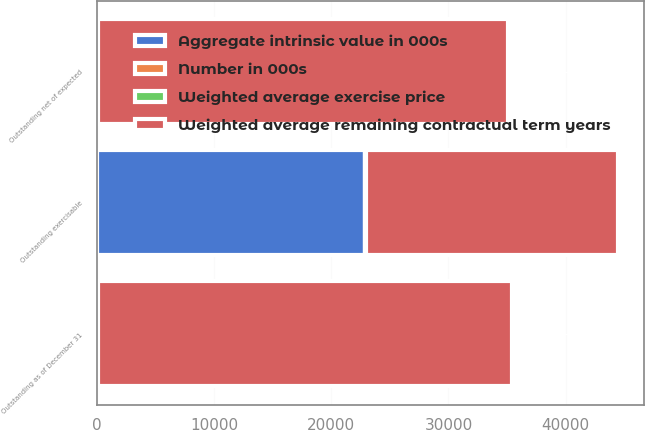Convert chart to OTSL. <chart><loc_0><loc_0><loc_500><loc_500><stacked_bar_chart><ecel><fcel>Outstanding as of December 31<fcel>Outstanding net of expected<fcel>Outstanding exercisable<nl><fcel>Weighted average remaining contractual term years<fcel>35296<fcel>34968<fcel>21470<nl><fcel>Weighted average exercise price<fcel>39.39<fcel>39.51<fcel>45.92<nl><fcel>Aggregate intrinsic value in 000s<fcel>42.715<fcel>42.715<fcel>22910<nl><fcel>Number in 000s<fcel>5.3<fcel>5.3<fcel>3.7<nl></chart> 